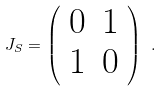Convert formula to latex. <formula><loc_0><loc_0><loc_500><loc_500>J _ { S } = \left ( \begin{array} { c c } 0 & 1 \\ 1 & 0 \end{array} \right ) \ .</formula> 